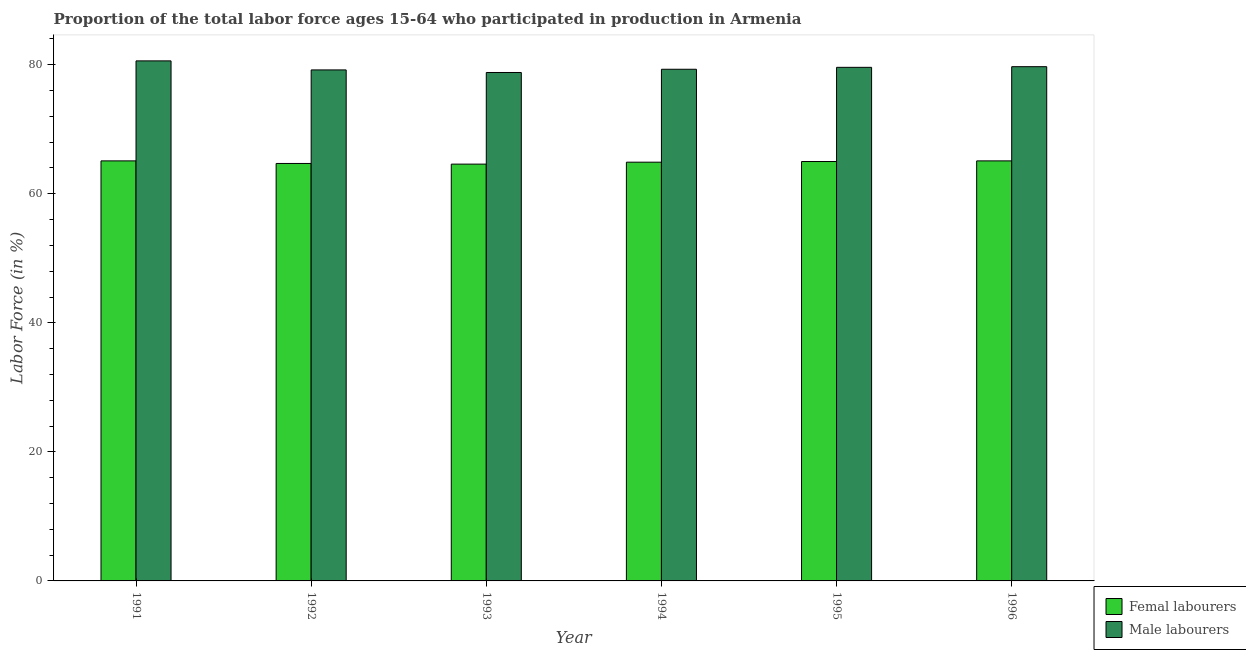Are the number of bars per tick equal to the number of legend labels?
Keep it short and to the point. Yes. How many bars are there on the 6th tick from the right?
Your response must be concise. 2. In how many cases, is the number of bars for a given year not equal to the number of legend labels?
Your answer should be compact. 0. What is the percentage of female labor force in 1994?
Your answer should be compact. 64.9. Across all years, what is the maximum percentage of male labour force?
Your response must be concise. 80.6. Across all years, what is the minimum percentage of male labour force?
Offer a very short reply. 78.8. In which year was the percentage of female labor force minimum?
Ensure brevity in your answer.  1993. What is the total percentage of female labor force in the graph?
Make the answer very short. 389.4. What is the difference between the percentage of male labour force in 1992 and that in 1993?
Your answer should be compact. 0.4. What is the difference between the percentage of female labor force in 1993 and the percentage of male labour force in 1995?
Give a very brief answer. -0.4. What is the average percentage of female labor force per year?
Your answer should be compact. 64.9. What is the ratio of the percentage of male labour force in 1995 to that in 1996?
Provide a succinct answer. 1. Is the difference between the percentage of female labor force in 1991 and 1996 greater than the difference between the percentage of male labour force in 1991 and 1996?
Make the answer very short. No. What is the difference between the highest and the second highest percentage of male labour force?
Make the answer very short. 0.9. What is the difference between the highest and the lowest percentage of male labour force?
Offer a terse response. 1.8. In how many years, is the percentage of male labour force greater than the average percentage of male labour force taken over all years?
Give a very brief answer. 3. What does the 1st bar from the left in 1991 represents?
Provide a succinct answer. Femal labourers. What does the 2nd bar from the right in 1996 represents?
Your answer should be compact. Femal labourers. What is the difference between two consecutive major ticks on the Y-axis?
Offer a very short reply. 20. Are the values on the major ticks of Y-axis written in scientific E-notation?
Ensure brevity in your answer.  No. Does the graph contain any zero values?
Your response must be concise. No. How many legend labels are there?
Offer a very short reply. 2. What is the title of the graph?
Your answer should be very brief. Proportion of the total labor force ages 15-64 who participated in production in Armenia. Does "Secondary" appear as one of the legend labels in the graph?
Your answer should be very brief. No. What is the label or title of the X-axis?
Your response must be concise. Year. What is the Labor Force (in %) of Femal labourers in 1991?
Your answer should be compact. 65.1. What is the Labor Force (in %) in Male labourers in 1991?
Give a very brief answer. 80.6. What is the Labor Force (in %) in Femal labourers in 1992?
Your answer should be compact. 64.7. What is the Labor Force (in %) in Male labourers in 1992?
Ensure brevity in your answer.  79.2. What is the Labor Force (in %) in Femal labourers in 1993?
Offer a terse response. 64.6. What is the Labor Force (in %) of Male labourers in 1993?
Ensure brevity in your answer.  78.8. What is the Labor Force (in %) of Femal labourers in 1994?
Provide a succinct answer. 64.9. What is the Labor Force (in %) of Male labourers in 1994?
Provide a succinct answer. 79.3. What is the Labor Force (in %) of Femal labourers in 1995?
Your response must be concise. 65. What is the Labor Force (in %) in Male labourers in 1995?
Give a very brief answer. 79.6. What is the Labor Force (in %) of Femal labourers in 1996?
Make the answer very short. 65.1. What is the Labor Force (in %) of Male labourers in 1996?
Ensure brevity in your answer.  79.7. Across all years, what is the maximum Labor Force (in %) in Femal labourers?
Make the answer very short. 65.1. Across all years, what is the maximum Labor Force (in %) of Male labourers?
Ensure brevity in your answer.  80.6. Across all years, what is the minimum Labor Force (in %) of Femal labourers?
Offer a very short reply. 64.6. Across all years, what is the minimum Labor Force (in %) of Male labourers?
Give a very brief answer. 78.8. What is the total Labor Force (in %) in Femal labourers in the graph?
Provide a short and direct response. 389.4. What is the total Labor Force (in %) of Male labourers in the graph?
Offer a terse response. 477.2. What is the difference between the Labor Force (in %) of Femal labourers in 1991 and that in 1992?
Your answer should be very brief. 0.4. What is the difference between the Labor Force (in %) in Male labourers in 1991 and that in 1993?
Provide a short and direct response. 1.8. What is the difference between the Labor Force (in %) in Femal labourers in 1991 and that in 1995?
Your response must be concise. 0.1. What is the difference between the Labor Force (in %) in Male labourers in 1991 and that in 1995?
Offer a terse response. 1. What is the difference between the Labor Force (in %) of Femal labourers in 1991 and that in 1996?
Your answer should be compact. 0. What is the difference between the Labor Force (in %) of Male labourers in 1991 and that in 1996?
Keep it short and to the point. 0.9. What is the difference between the Labor Force (in %) in Femal labourers in 1992 and that in 1993?
Ensure brevity in your answer.  0.1. What is the difference between the Labor Force (in %) of Male labourers in 1992 and that in 1993?
Your response must be concise. 0.4. What is the difference between the Labor Force (in %) of Femal labourers in 1992 and that in 1994?
Provide a short and direct response. -0.2. What is the difference between the Labor Force (in %) in Femal labourers in 1992 and that in 1995?
Make the answer very short. -0.3. What is the difference between the Labor Force (in %) of Male labourers in 1992 and that in 1996?
Your response must be concise. -0.5. What is the difference between the Labor Force (in %) of Femal labourers in 1993 and that in 1994?
Give a very brief answer. -0.3. What is the difference between the Labor Force (in %) in Femal labourers in 1993 and that in 1995?
Ensure brevity in your answer.  -0.4. What is the difference between the Labor Force (in %) in Male labourers in 1993 and that in 1995?
Provide a short and direct response. -0.8. What is the difference between the Labor Force (in %) in Male labourers in 1993 and that in 1996?
Keep it short and to the point. -0.9. What is the difference between the Labor Force (in %) in Male labourers in 1994 and that in 1995?
Ensure brevity in your answer.  -0.3. What is the difference between the Labor Force (in %) of Femal labourers in 1995 and that in 1996?
Your response must be concise. -0.1. What is the difference between the Labor Force (in %) of Male labourers in 1995 and that in 1996?
Provide a succinct answer. -0.1. What is the difference between the Labor Force (in %) in Femal labourers in 1991 and the Labor Force (in %) in Male labourers in 1992?
Offer a very short reply. -14.1. What is the difference between the Labor Force (in %) of Femal labourers in 1991 and the Labor Force (in %) of Male labourers in 1993?
Offer a very short reply. -13.7. What is the difference between the Labor Force (in %) in Femal labourers in 1991 and the Labor Force (in %) in Male labourers in 1995?
Make the answer very short. -14.5. What is the difference between the Labor Force (in %) of Femal labourers in 1991 and the Labor Force (in %) of Male labourers in 1996?
Offer a very short reply. -14.6. What is the difference between the Labor Force (in %) in Femal labourers in 1992 and the Labor Force (in %) in Male labourers in 1993?
Keep it short and to the point. -14.1. What is the difference between the Labor Force (in %) in Femal labourers in 1992 and the Labor Force (in %) in Male labourers in 1994?
Ensure brevity in your answer.  -14.6. What is the difference between the Labor Force (in %) of Femal labourers in 1992 and the Labor Force (in %) of Male labourers in 1995?
Make the answer very short. -14.9. What is the difference between the Labor Force (in %) of Femal labourers in 1993 and the Labor Force (in %) of Male labourers in 1994?
Offer a terse response. -14.7. What is the difference between the Labor Force (in %) of Femal labourers in 1993 and the Labor Force (in %) of Male labourers in 1996?
Offer a terse response. -15.1. What is the difference between the Labor Force (in %) in Femal labourers in 1994 and the Labor Force (in %) in Male labourers in 1995?
Your answer should be compact. -14.7. What is the difference between the Labor Force (in %) in Femal labourers in 1994 and the Labor Force (in %) in Male labourers in 1996?
Ensure brevity in your answer.  -14.8. What is the difference between the Labor Force (in %) in Femal labourers in 1995 and the Labor Force (in %) in Male labourers in 1996?
Your response must be concise. -14.7. What is the average Labor Force (in %) of Femal labourers per year?
Your response must be concise. 64.9. What is the average Labor Force (in %) in Male labourers per year?
Give a very brief answer. 79.53. In the year 1991, what is the difference between the Labor Force (in %) in Femal labourers and Labor Force (in %) in Male labourers?
Offer a very short reply. -15.5. In the year 1993, what is the difference between the Labor Force (in %) of Femal labourers and Labor Force (in %) of Male labourers?
Keep it short and to the point. -14.2. In the year 1994, what is the difference between the Labor Force (in %) of Femal labourers and Labor Force (in %) of Male labourers?
Give a very brief answer. -14.4. In the year 1995, what is the difference between the Labor Force (in %) of Femal labourers and Labor Force (in %) of Male labourers?
Make the answer very short. -14.6. In the year 1996, what is the difference between the Labor Force (in %) of Femal labourers and Labor Force (in %) of Male labourers?
Provide a succinct answer. -14.6. What is the ratio of the Labor Force (in %) of Male labourers in 1991 to that in 1992?
Your answer should be compact. 1.02. What is the ratio of the Labor Force (in %) in Femal labourers in 1991 to that in 1993?
Provide a short and direct response. 1.01. What is the ratio of the Labor Force (in %) of Male labourers in 1991 to that in 1993?
Offer a terse response. 1.02. What is the ratio of the Labor Force (in %) of Femal labourers in 1991 to that in 1994?
Provide a succinct answer. 1. What is the ratio of the Labor Force (in %) of Male labourers in 1991 to that in 1994?
Provide a succinct answer. 1.02. What is the ratio of the Labor Force (in %) of Femal labourers in 1991 to that in 1995?
Make the answer very short. 1. What is the ratio of the Labor Force (in %) of Male labourers in 1991 to that in 1995?
Offer a terse response. 1.01. What is the ratio of the Labor Force (in %) in Femal labourers in 1991 to that in 1996?
Your answer should be compact. 1. What is the ratio of the Labor Force (in %) in Male labourers in 1991 to that in 1996?
Give a very brief answer. 1.01. What is the ratio of the Labor Force (in %) in Femal labourers in 1992 to that in 1993?
Your answer should be compact. 1. What is the ratio of the Labor Force (in %) of Male labourers in 1992 to that in 1994?
Give a very brief answer. 1. What is the ratio of the Labor Force (in %) of Femal labourers in 1992 to that in 1995?
Your answer should be compact. 1. What is the ratio of the Labor Force (in %) of Male labourers in 1992 to that in 1995?
Offer a very short reply. 0.99. What is the ratio of the Labor Force (in %) in Femal labourers in 1993 to that in 1994?
Provide a short and direct response. 1. What is the ratio of the Labor Force (in %) in Femal labourers in 1993 to that in 1996?
Provide a short and direct response. 0.99. What is the ratio of the Labor Force (in %) in Male labourers in 1993 to that in 1996?
Ensure brevity in your answer.  0.99. What is the ratio of the Labor Force (in %) of Femal labourers in 1994 to that in 1995?
Your response must be concise. 1. What is the ratio of the Labor Force (in %) of Femal labourers in 1994 to that in 1996?
Provide a short and direct response. 1. What is the ratio of the Labor Force (in %) in Male labourers in 1995 to that in 1996?
Your answer should be compact. 1. What is the difference between the highest and the lowest Labor Force (in %) of Femal labourers?
Ensure brevity in your answer.  0.5. 